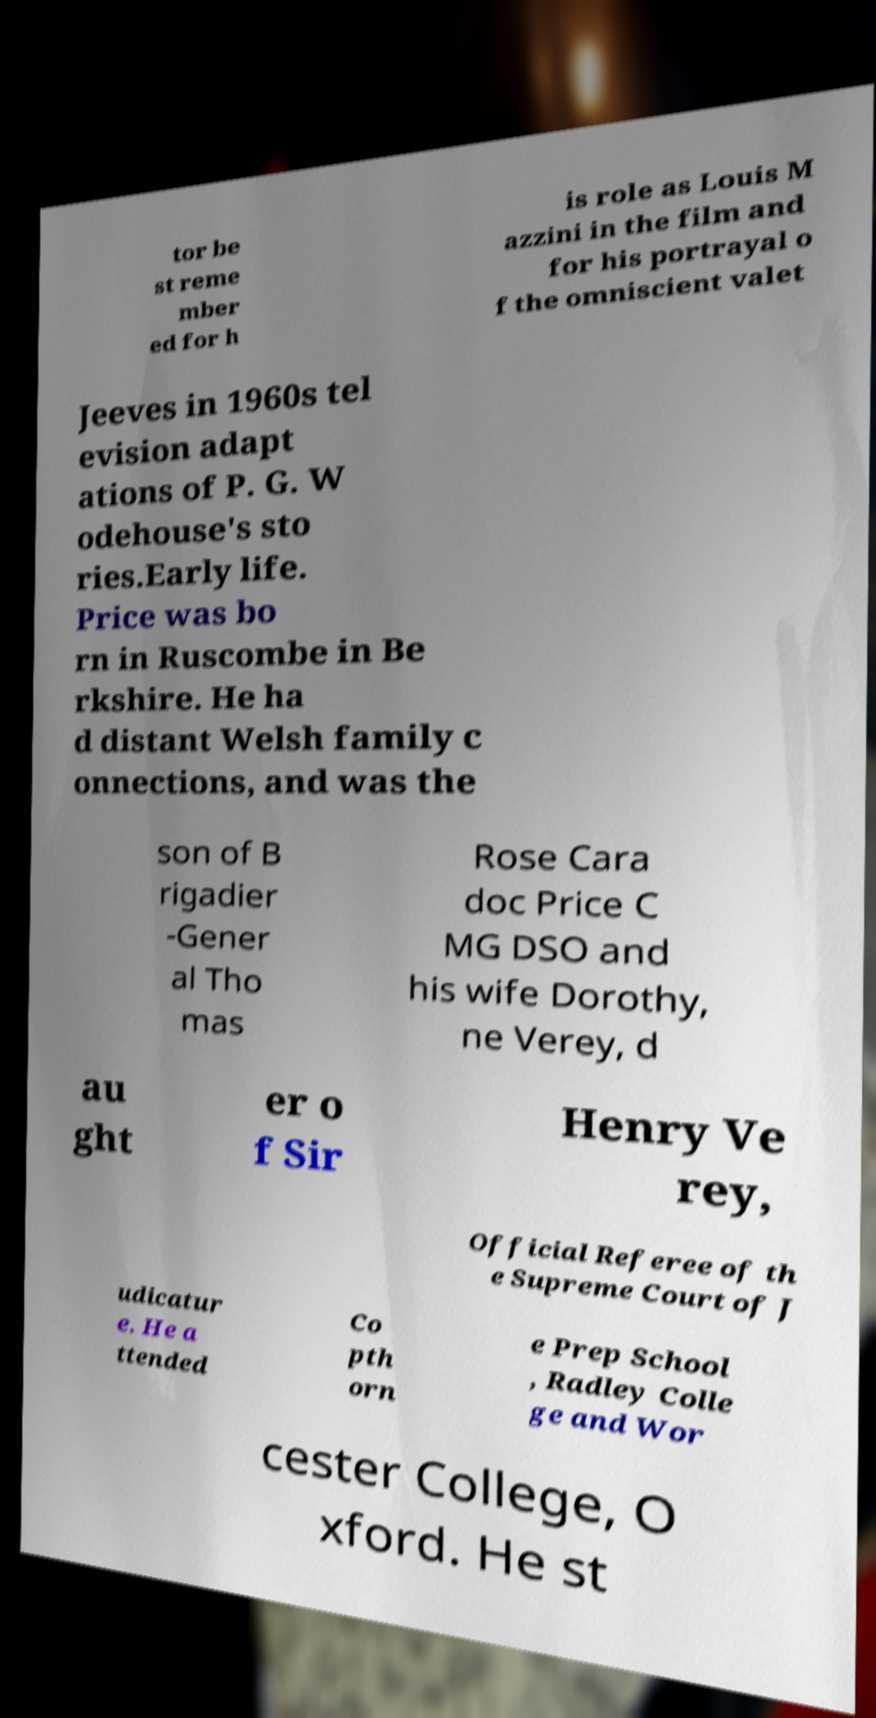For documentation purposes, I need the text within this image transcribed. Could you provide that? tor be st reme mber ed for h is role as Louis M azzini in the film and for his portrayal o f the omniscient valet Jeeves in 1960s tel evision adapt ations of P. G. W odehouse's sto ries.Early life. Price was bo rn in Ruscombe in Be rkshire. He ha d distant Welsh family c onnections, and was the son of B rigadier -Gener al Tho mas Rose Cara doc Price C MG DSO and his wife Dorothy, ne Verey, d au ght er o f Sir Henry Ve rey, Official Referee of th e Supreme Court of J udicatur e. He a ttended Co pth orn e Prep School , Radley Colle ge and Wor cester College, O xford. He st 